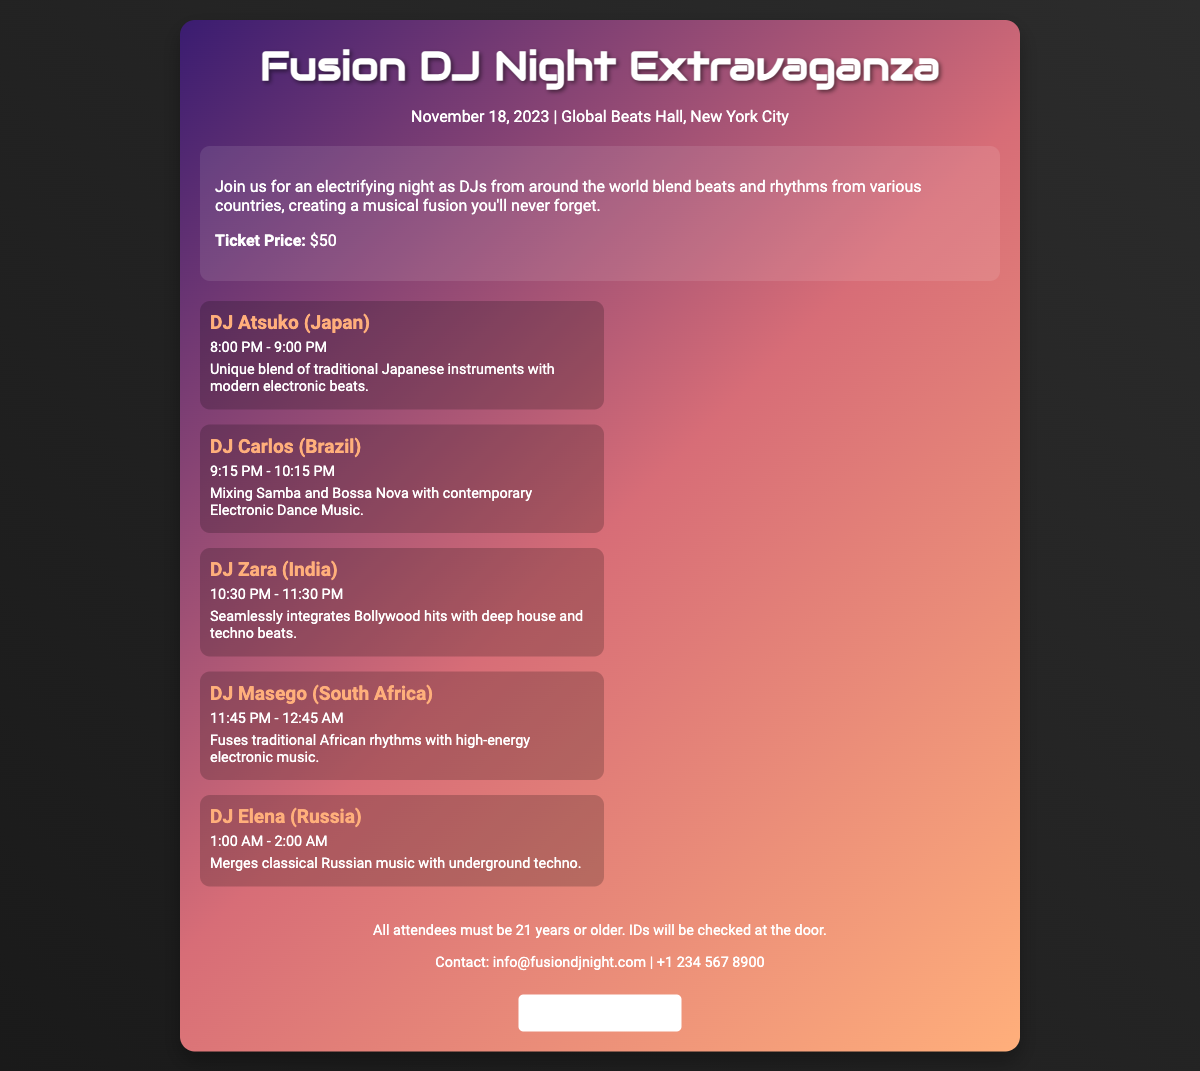What date is the concert? The concert date is clearly mentioned as November 18, 2023 in the document.
Answer: November 18, 2023 What is the ticket price? The document states the ticket price is $50.
Answer: $50 Who is performing at 10:30 PM? The document lists the artist DJ Zara with the performance time at 10:30 PM - 11:30 PM.
Answer: DJ Zara What genre does DJ Masego fuse? The document describes DJ Masego as fusing traditional African rhythms with high-energy electronic music.
Answer: Traditional African rhythms with electronic music What is the age requirement for attendees? The document specifies that all attendees must be 21 years or older, which indicates the minimum age limit.
Answer: 21 years or older Which artist represents Russia? The document clearly states that DJ Elena is the artist from Russia.
Answer: DJ Elena What type of music does DJ Atsuko blend? The document mentions DJ Atsuko blending traditional Japanese instruments with modern electronic beats.
Answer: Traditional Japanese instruments with modern electronic beats What performance time does DJ Carlos have? The schedule shows that DJ Carlos performs from 9:15 PM - 10:15 PM.
Answer: 9:15 PM - 10:15 PM What contact information is provided? The contact information for inquiries is shown as info@fusiondjnight.com
Answer: info@fusiondjnight.com 